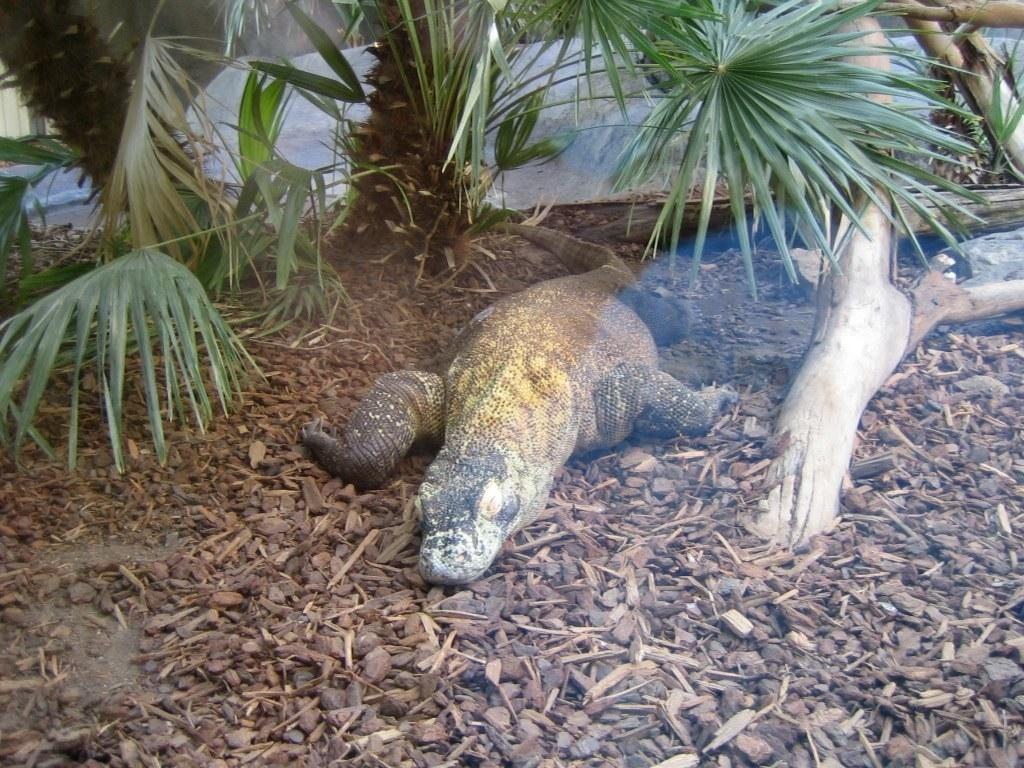What type of animal is in the picture? There is an animal in the picture, but the specific type cannot be determined from the provided facts. What can be seen in the background of the picture? There are trees visible in the background. What is present at the bottom of the picture? There are stones and wooden pieces at the bottom of the picture. What object is present in the picture that is typically found on trees? There is a tree branch in the picture. What type of calendar is hanging on the tree branch in the picture? There is no calendar present in the picture; only an animal, trees, stones, wooden pieces, and a tree branch are visible. What type of letter is the animal holding in the picture? There is no letter present in the picture; only an animal, trees, stones, wooden pieces, and a tree branch are visible. 